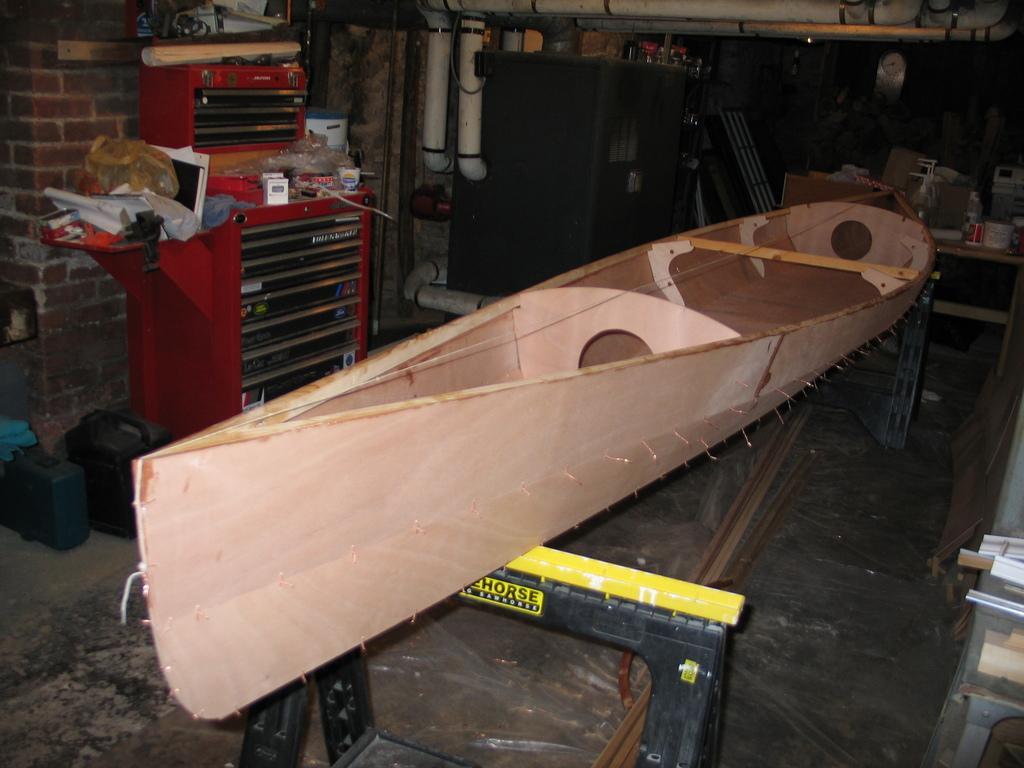Can you describe this image briefly? We can see boat on stands. On the left side of the image we can see boxes on the floor and so many things on red object. In the background we can see pipes,wall,clock,some objects on the table and few objects on the surface 